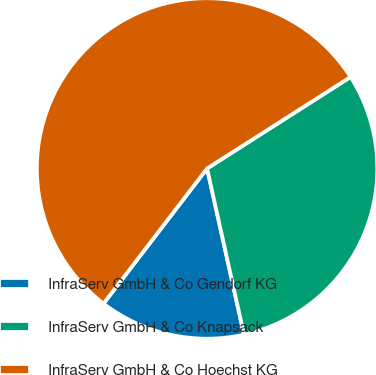<chart> <loc_0><loc_0><loc_500><loc_500><pie_chart><fcel>InfraServ GmbH & Co Gendorf KG<fcel>InfraServ GmbH & Co Knapsack<fcel>InfraServ GmbH & Co Hoechst KG<nl><fcel>13.89%<fcel>30.56%<fcel>55.56%<nl></chart> 